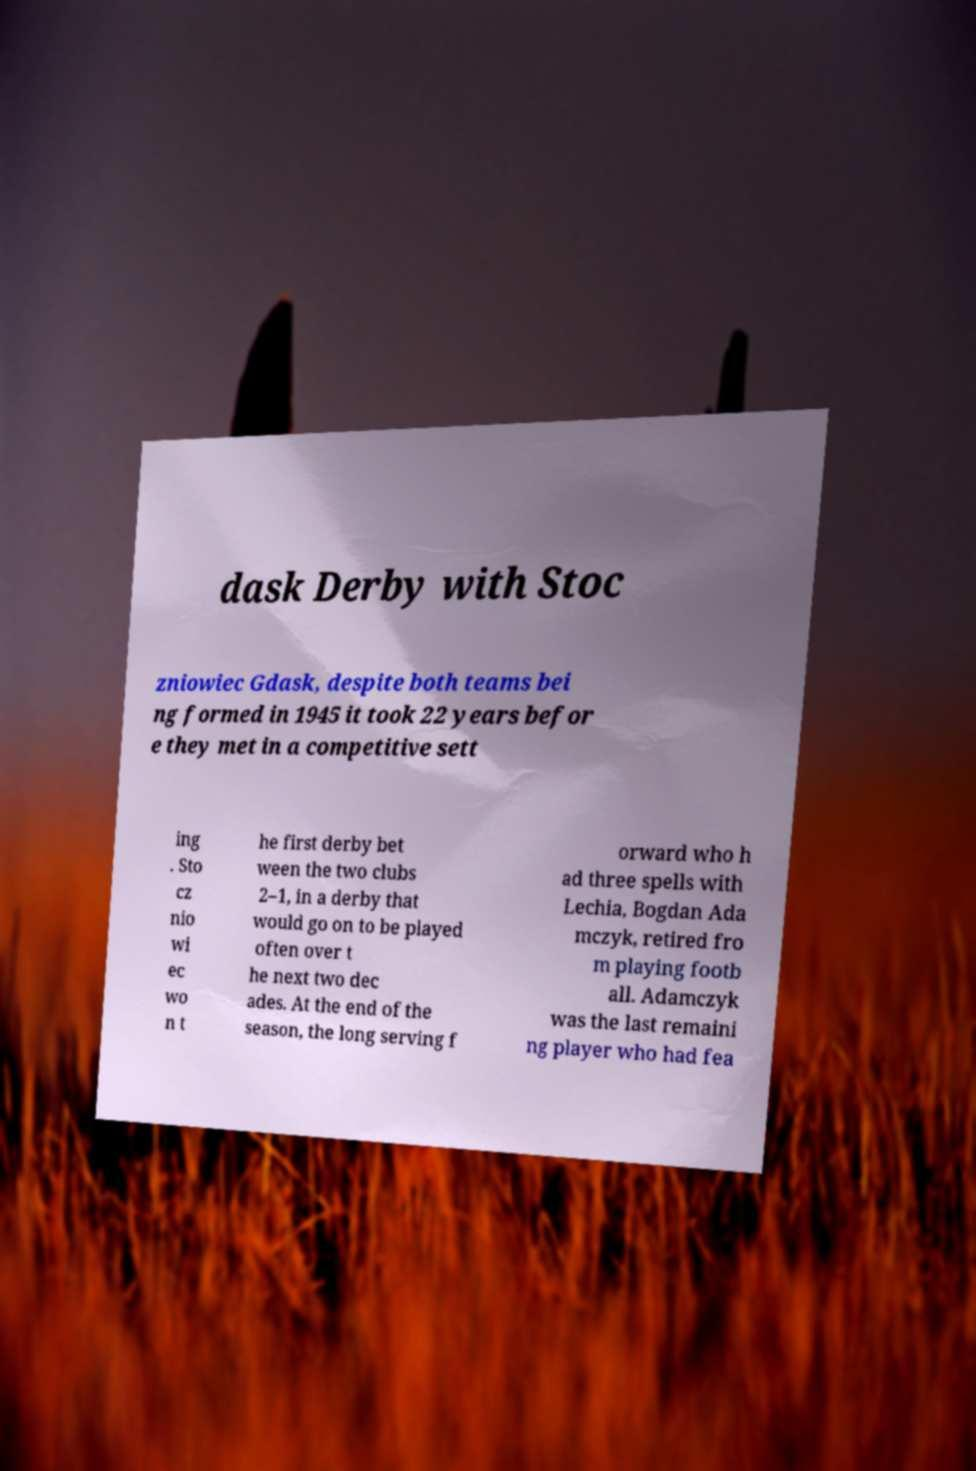Can you read and provide the text displayed in the image?This photo seems to have some interesting text. Can you extract and type it out for me? dask Derby with Stoc zniowiec Gdask, despite both teams bei ng formed in 1945 it took 22 years befor e they met in a competitive sett ing . Sto cz nio wi ec wo n t he first derby bet ween the two clubs 2–1, in a derby that would go on to be played often over t he next two dec ades. At the end of the season, the long serving f orward who h ad three spells with Lechia, Bogdan Ada mczyk, retired fro m playing footb all. Adamczyk was the last remaini ng player who had fea 